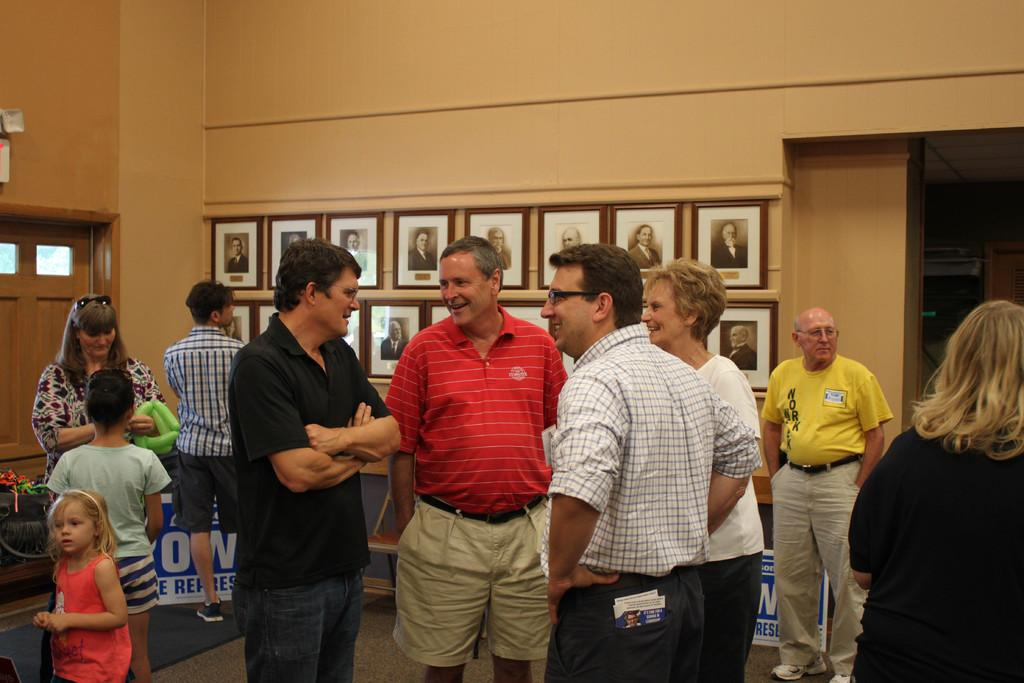What are the people in the image doing? The people in the image are standing on the floor. What can be seen on the walls in the background of the image? There are photo frames attached to the walls in the background of the image. What architectural features are visible in the background of the image? There are doors and windows visible in the background of the image. What type of temper do the waves have in the image? There are no waves present in the image. How many men are visible in the image? The image does not show any men; it only shows people standing on the floor. 